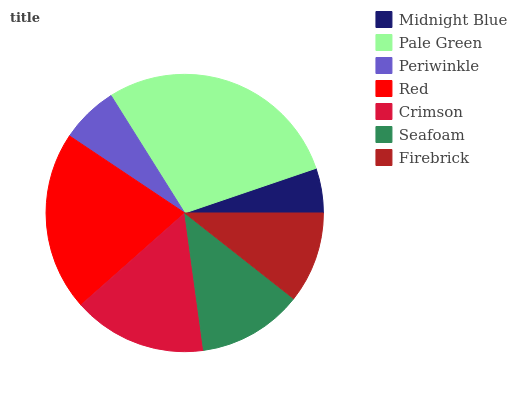Is Midnight Blue the minimum?
Answer yes or no. Yes. Is Pale Green the maximum?
Answer yes or no. Yes. Is Periwinkle the minimum?
Answer yes or no. No. Is Periwinkle the maximum?
Answer yes or no. No. Is Pale Green greater than Periwinkle?
Answer yes or no. Yes. Is Periwinkle less than Pale Green?
Answer yes or no. Yes. Is Periwinkle greater than Pale Green?
Answer yes or no. No. Is Pale Green less than Periwinkle?
Answer yes or no. No. Is Seafoam the high median?
Answer yes or no. Yes. Is Seafoam the low median?
Answer yes or no. Yes. Is Red the high median?
Answer yes or no. No. Is Firebrick the low median?
Answer yes or no. No. 